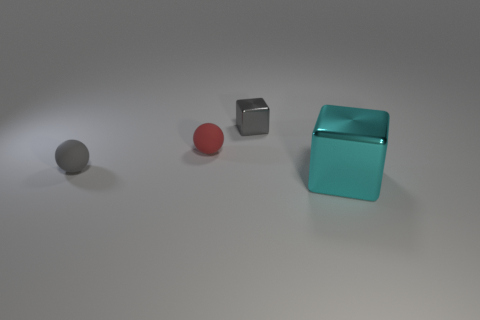Add 2 green shiny spheres. How many objects exist? 6 Subtract all gray blocks. How many blocks are left? 1 Subtract 1 balls. How many balls are left? 1 Subtract 0 purple balls. How many objects are left? 4 Subtract all gray blocks. Subtract all red cylinders. How many blocks are left? 1 Subtract all brown blocks. How many red spheres are left? 1 Subtract all blue shiny blocks. Subtract all small gray balls. How many objects are left? 3 Add 2 tiny gray metallic blocks. How many tiny gray metallic blocks are left? 3 Add 4 cyan objects. How many cyan objects exist? 5 